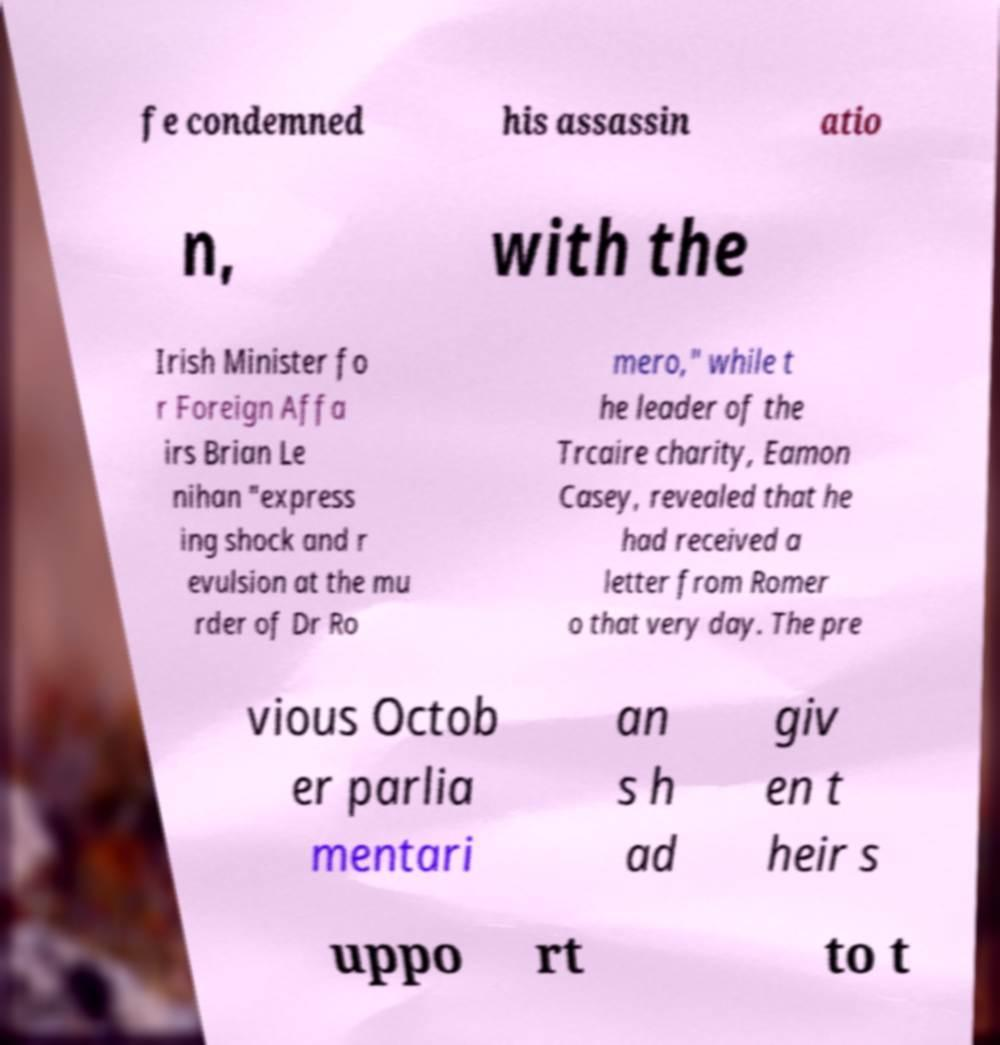Please read and relay the text visible in this image. What does it say? fe condemned his assassin atio n, with the Irish Minister fo r Foreign Affa irs Brian Le nihan "express ing shock and r evulsion at the mu rder of Dr Ro mero," while t he leader of the Trcaire charity, Eamon Casey, revealed that he had received a letter from Romer o that very day. The pre vious Octob er parlia mentari an s h ad giv en t heir s uppo rt to t 